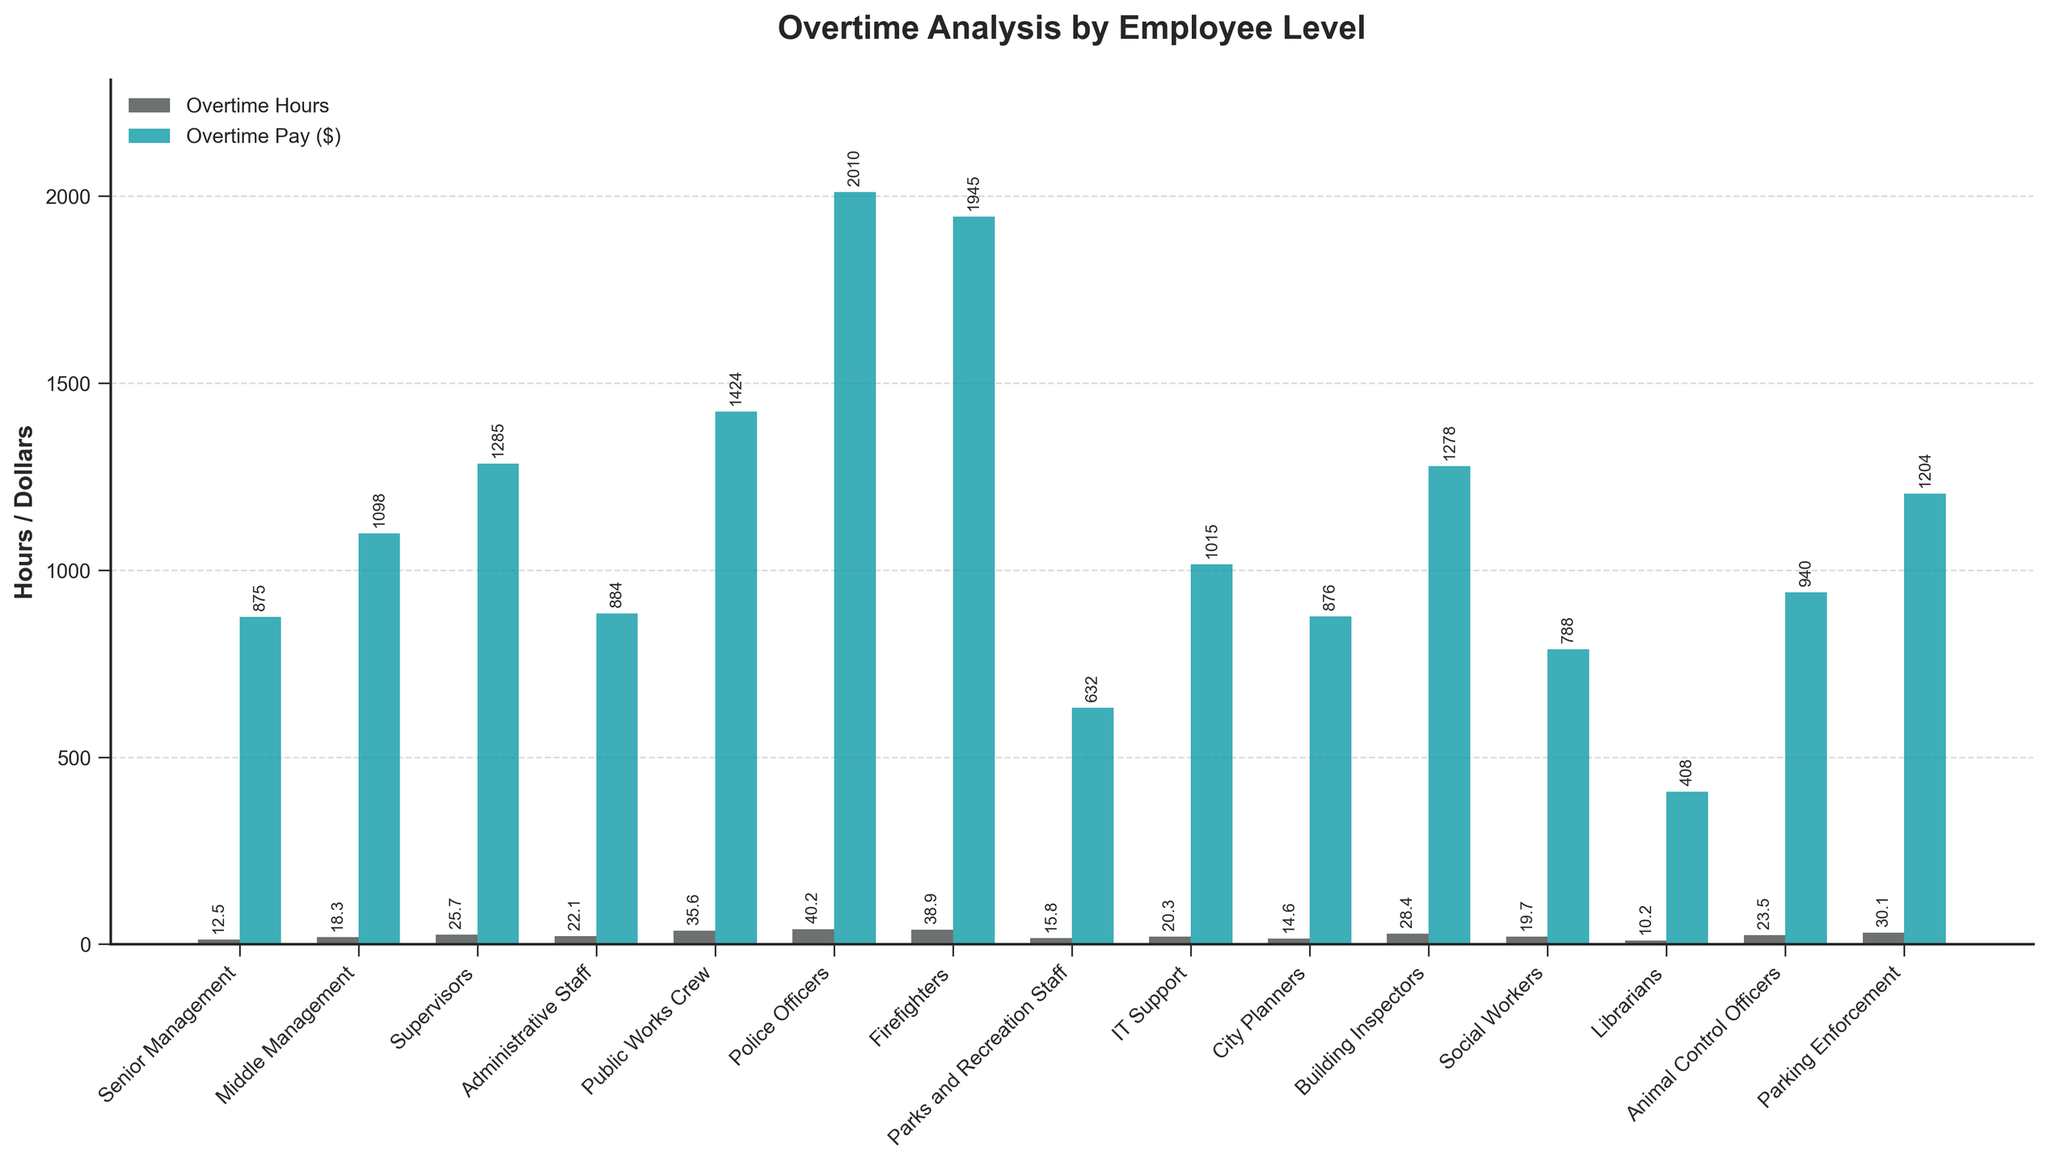Which employee level has the highest average overtime pay? By observing the heights of the bars representing Average Overtime Pay, Police Officers have the highest bar.
Answer: Police Officers Which employee level has the greatest discrepancy between overtime hours and pay? Comparing the difference between the two bars for each employee level, Police Officers show a significant difference, with high overtime hours and the highest overtime pay.
Answer: Police Officers Which employee level has the fewest average overtime hours? The shortest bar for Average Overtime Hours corresponds to Librarians.
Answer: Librarians What is the sum of average overtime pay for Senior Management and City Planners? Senior Management has an average overtime pay of $875, and City Planners have $876. So, $875 + $876 = $1751.
Answer: $1751 Which group works more overtime hours on average, Administrative Staff or IT Support? The bar for Average Overtime Hours is slightly higher for Administrative Staff (22.1) compared to IT Support (20.3).
Answer: Administrative Staff What is the approximate combined average overtime pay for Public Works Crew and Firefighters? Public Works Crew has an average overtime pay of $1424, and Firefighters have $1945. So, $1424 + $1945 ≈ $3369.
Answer: $3369 Are Police Officers and Firefighters' average overtime pays roughly equal? The bars for Average Overtime Pay of Police Officers ($2010) and Firefighters ($1945) are very close but not equal.
Answer: No Which employee level earns slightly more in average overtime pay, Supervisors or Building Inspectors? Comparing the height of the bars for Average Overtime Pay, Supervisors earn $1285, whereas Building Inspectors earn $1278.
Answer: Supervisors How much more is the average overtime pay of Police Officers compared to Parks and Recreation Staff? Police Officers have $2010 in pay and Parks and Recreation Staff have $632. So, $2010 - $632 = $1378.
Answer: $1378 Which employee level has nearly equal average overtime hours and pay? By comparing the approximate heights of the bars, Senior Management has 12.5 average overtime hours and $875 in pay, which are nearly equal.
Answer: Senior Management 